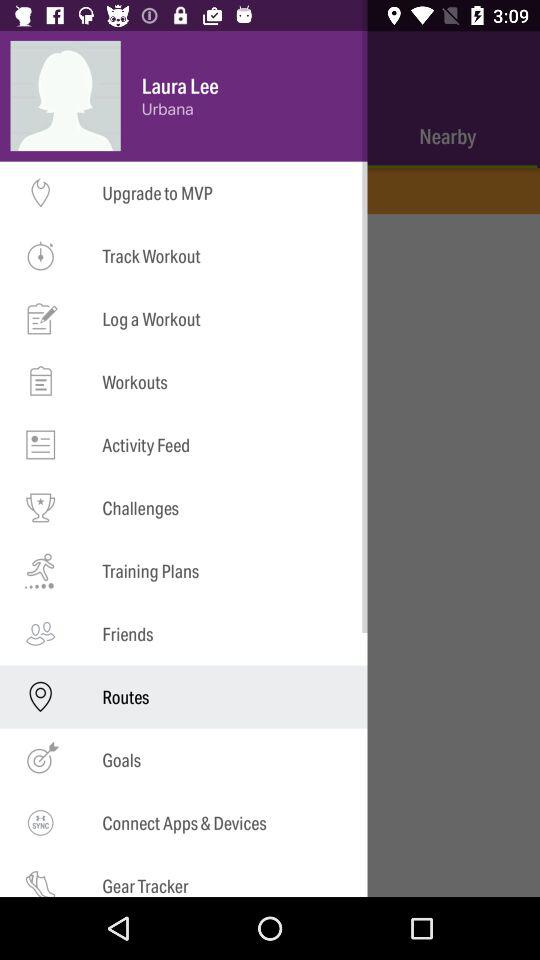Which option is selected? The selected option is "Routes". 